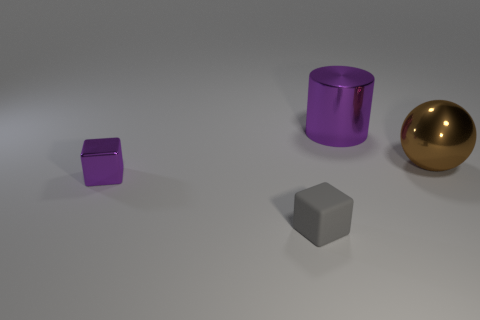What color is the other small thing that is the same shape as the small purple metal thing?
Your response must be concise. Gray. Do the big purple thing and the metallic object that is in front of the ball have the same shape?
Your answer should be very brief. No. There is a object that is both on the left side of the large metal cylinder and right of the metallic block; what color is it?
Offer a very short reply. Gray. Are there any green matte things of the same shape as the gray thing?
Ensure brevity in your answer.  No. Do the matte block and the metal sphere have the same color?
Your answer should be compact. No. There is a small block in front of the purple metal block; is there a small gray rubber block that is behind it?
Provide a succinct answer. No. What number of objects are either purple objects that are left of the small gray block or shiny objects in front of the metal ball?
Your answer should be very brief. 1. What number of things are either big gray shiny spheres or objects that are in front of the brown ball?
Offer a very short reply. 2. What size is the purple metal object on the left side of the big purple object that is on the right side of the block that is on the right side of the small purple metallic cube?
Your answer should be compact. Small. What material is the purple cylinder that is the same size as the brown metallic object?
Your response must be concise. Metal. 